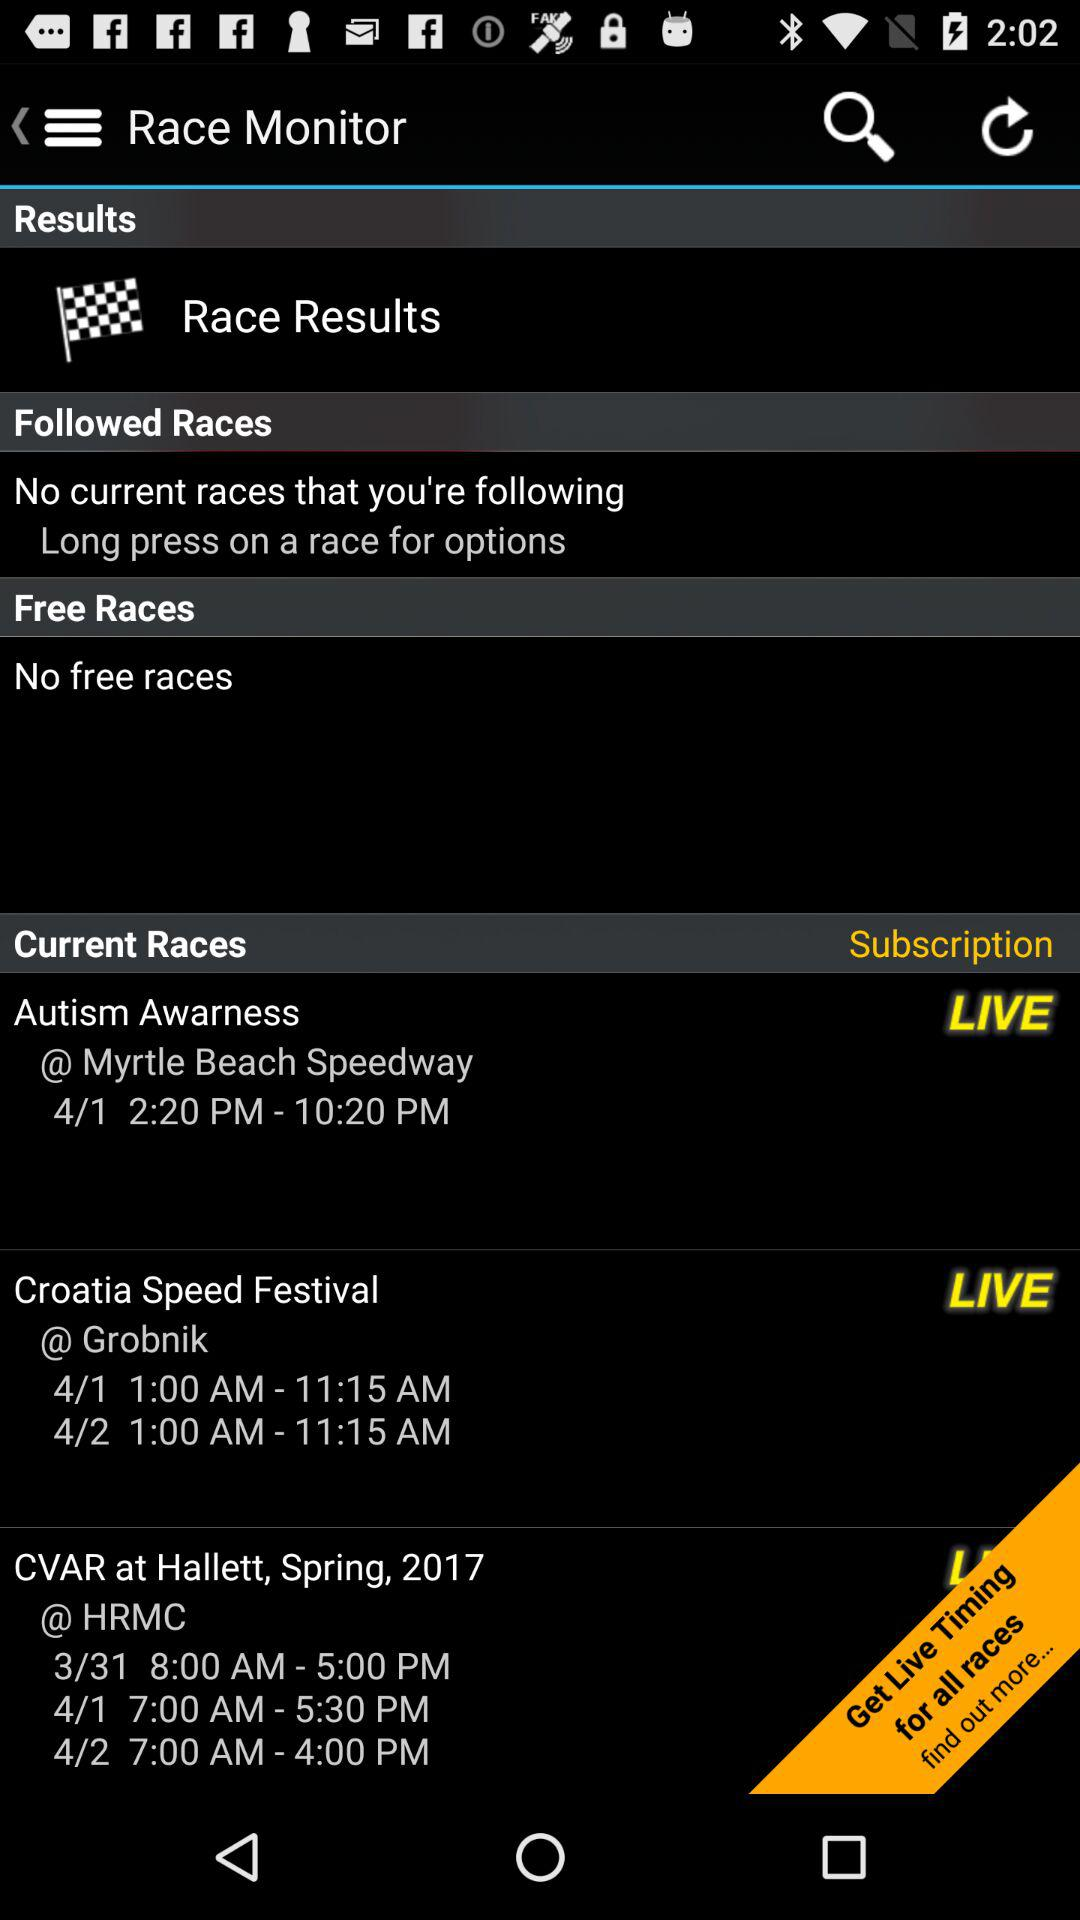Are there any races available today? Yes, according to the image there are races available today. The 'Autism Awareness' event at Myrtle Beach Speedway is ongoing, as well as the 'Croatia Speed Festival' at Grobnik. What times do these events start and end today? The 'Autism Awareness' event at Myrtle Beach Speedway runs from 2:20 PM to 10:20 PM, and the 'Croatia Speed Festival' at Grobnik is from 1:00 AM to 11:15 AM on the current day according to the image. 